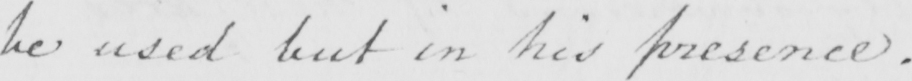Transcribe the text shown in this historical manuscript line. be sued but in his presence . 